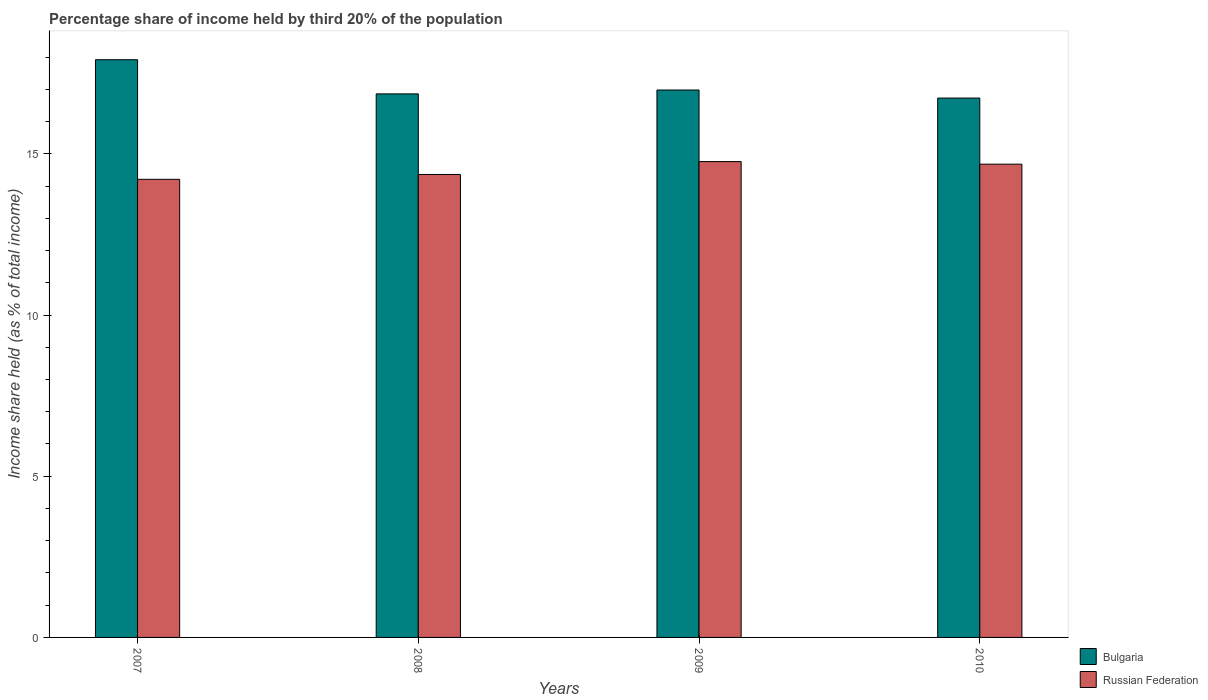How many different coloured bars are there?
Provide a short and direct response. 2. Are the number of bars on each tick of the X-axis equal?
Ensure brevity in your answer.  Yes. How many bars are there on the 4th tick from the left?
Give a very brief answer. 2. What is the label of the 3rd group of bars from the left?
Give a very brief answer. 2009. In how many cases, is the number of bars for a given year not equal to the number of legend labels?
Offer a terse response. 0. What is the share of income held by third 20% of the population in Russian Federation in 2007?
Your answer should be very brief. 14.21. Across all years, what is the maximum share of income held by third 20% of the population in Russian Federation?
Ensure brevity in your answer.  14.76. Across all years, what is the minimum share of income held by third 20% of the population in Russian Federation?
Give a very brief answer. 14.21. In which year was the share of income held by third 20% of the population in Bulgaria minimum?
Offer a terse response. 2010. What is the total share of income held by third 20% of the population in Bulgaria in the graph?
Your answer should be compact. 68.49. What is the difference between the share of income held by third 20% of the population in Bulgaria in 2008 and that in 2009?
Your answer should be compact. -0.12. What is the difference between the share of income held by third 20% of the population in Bulgaria in 2007 and the share of income held by third 20% of the population in Russian Federation in 2008?
Offer a very short reply. 3.56. What is the average share of income held by third 20% of the population in Bulgaria per year?
Offer a very short reply. 17.12. In the year 2007, what is the difference between the share of income held by third 20% of the population in Bulgaria and share of income held by third 20% of the population in Russian Federation?
Offer a very short reply. 3.71. In how many years, is the share of income held by third 20% of the population in Bulgaria greater than 16 %?
Make the answer very short. 4. What is the ratio of the share of income held by third 20% of the population in Bulgaria in 2008 to that in 2010?
Give a very brief answer. 1.01. Is the share of income held by third 20% of the population in Bulgaria in 2007 less than that in 2008?
Your answer should be compact. No. What is the difference between the highest and the second highest share of income held by third 20% of the population in Russian Federation?
Give a very brief answer. 0.08. What is the difference between the highest and the lowest share of income held by third 20% of the population in Russian Federation?
Your response must be concise. 0.55. In how many years, is the share of income held by third 20% of the population in Russian Federation greater than the average share of income held by third 20% of the population in Russian Federation taken over all years?
Make the answer very short. 2. Is the sum of the share of income held by third 20% of the population in Bulgaria in 2007 and 2008 greater than the maximum share of income held by third 20% of the population in Russian Federation across all years?
Provide a succinct answer. Yes. What does the 1st bar from the right in 2007 represents?
Provide a short and direct response. Russian Federation. Are all the bars in the graph horizontal?
Your answer should be very brief. No. What is the difference between two consecutive major ticks on the Y-axis?
Offer a terse response. 5. Are the values on the major ticks of Y-axis written in scientific E-notation?
Make the answer very short. No. How are the legend labels stacked?
Make the answer very short. Vertical. What is the title of the graph?
Offer a terse response. Percentage share of income held by third 20% of the population. What is the label or title of the Y-axis?
Your response must be concise. Income share held (as % of total income). What is the Income share held (as % of total income) of Bulgaria in 2007?
Make the answer very short. 17.92. What is the Income share held (as % of total income) of Russian Federation in 2007?
Ensure brevity in your answer.  14.21. What is the Income share held (as % of total income) in Bulgaria in 2008?
Keep it short and to the point. 16.86. What is the Income share held (as % of total income) in Russian Federation in 2008?
Your answer should be very brief. 14.36. What is the Income share held (as % of total income) of Bulgaria in 2009?
Give a very brief answer. 16.98. What is the Income share held (as % of total income) of Russian Federation in 2009?
Provide a succinct answer. 14.76. What is the Income share held (as % of total income) in Bulgaria in 2010?
Your response must be concise. 16.73. What is the Income share held (as % of total income) in Russian Federation in 2010?
Offer a terse response. 14.68. Across all years, what is the maximum Income share held (as % of total income) of Bulgaria?
Keep it short and to the point. 17.92. Across all years, what is the maximum Income share held (as % of total income) of Russian Federation?
Your answer should be compact. 14.76. Across all years, what is the minimum Income share held (as % of total income) in Bulgaria?
Provide a short and direct response. 16.73. Across all years, what is the minimum Income share held (as % of total income) of Russian Federation?
Offer a very short reply. 14.21. What is the total Income share held (as % of total income) in Bulgaria in the graph?
Ensure brevity in your answer.  68.49. What is the total Income share held (as % of total income) of Russian Federation in the graph?
Offer a very short reply. 58.01. What is the difference between the Income share held (as % of total income) of Bulgaria in 2007 and that in 2008?
Your answer should be compact. 1.06. What is the difference between the Income share held (as % of total income) in Bulgaria in 2007 and that in 2009?
Provide a succinct answer. 0.94. What is the difference between the Income share held (as % of total income) of Russian Federation in 2007 and that in 2009?
Offer a terse response. -0.55. What is the difference between the Income share held (as % of total income) of Bulgaria in 2007 and that in 2010?
Offer a very short reply. 1.19. What is the difference between the Income share held (as % of total income) of Russian Federation in 2007 and that in 2010?
Give a very brief answer. -0.47. What is the difference between the Income share held (as % of total income) of Bulgaria in 2008 and that in 2009?
Offer a very short reply. -0.12. What is the difference between the Income share held (as % of total income) in Bulgaria in 2008 and that in 2010?
Provide a short and direct response. 0.13. What is the difference between the Income share held (as % of total income) in Russian Federation in 2008 and that in 2010?
Make the answer very short. -0.32. What is the difference between the Income share held (as % of total income) of Bulgaria in 2007 and the Income share held (as % of total income) of Russian Federation in 2008?
Your answer should be compact. 3.56. What is the difference between the Income share held (as % of total income) of Bulgaria in 2007 and the Income share held (as % of total income) of Russian Federation in 2009?
Offer a very short reply. 3.16. What is the difference between the Income share held (as % of total income) of Bulgaria in 2007 and the Income share held (as % of total income) of Russian Federation in 2010?
Keep it short and to the point. 3.24. What is the difference between the Income share held (as % of total income) of Bulgaria in 2008 and the Income share held (as % of total income) of Russian Federation in 2009?
Ensure brevity in your answer.  2.1. What is the difference between the Income share held (as % of total income) in Bulgaria in 2008 and the Income share held (as % of total income) in Russian Federation in 2010?
Provide a short and direct response. 2.18. What is the average Income share held (as % of total income) of Bulgaria per year?
Ensure brevity in your answer.  17.12. What is the average Income share held (as % of total income) of Russian Federation per year?
Give a very brief answer. 14.5. In the year 2007, what is the difference between the Income share held (as % of total income) in Bulgaria and Income share held (as % of total income) in Russian Federation?
Offer a very short reply. 3.71. In the year 2008, what is the difference between the Income share held (as % of total income) of Bulgaria and Income share held (as % of total income) of Russian Federation?
Your answer should be very brief. 2.5. In the year 2009, what is the difference between the Income share held (as % of total income) in Bulgaria and Income share held (as % of total income) in Russian Federation?
Keep it short and to the point. 2.22. In the year 2010, what is the difference between the Income share held (as % of total income) in Bulgaria and Income share held (as % of total income) in Russian Federation?
Offer a terse response. 2.05. What is the ratio of the Income share held (as % of total income) in Bulgaria in 2007 to that in 2008?
Provide a succinct answer. 1.06. What is the ratio of the Income share held (as % of total income) of Russian Federation in 2007 to that in 2008?
Keep it short and to the point. 0.99. What is the ratio of the Income share held (as % of total income) in Bulgaria in 2007 to that in 2009?
Make the answer very short. 1.06. What is the ratio of the Income share held (as % of total income) in Russian Federation in 2007 to that in 2009?
Keep it short and to the point. 0.96. What is the ratio of the Income share held (as % of total income) of Bulgaria in 2007 to that in 2010?
Offer a terse response. 1.07. What is the ratio of the Income share held (as % of total income) of Bulgaria in 2008 to that in 2009?
Offer a terse response. 0.99. What is the ratio of the Income share held (as % of total income) in Russian Federation in 2008 to that in 2009?
Your answer should be very brief. 0.97. What is the ratio of the Income share held (as % of total income) of Bulgaria in 2008 to that in 2010?
Provide a succinct answer. 1.01. What is the ratio of the Income share held (as % of total income) of Russian Federation in 2008 to that in 2010?
Provide a succinct answer. 0.98. What is the ratio of the Income share held (as % of total income) of Bulgaria in 2009 to that in 2010?
Offer a terse response. 1.01. What is the ratio of the Income share held (as % of total income) in Russian Federation in 2009 to that in 2010?
Your answer should be compact. 1.01. What is the difference between the highest and the lowest Income share held (as % of total income) of Bulgaria?
Your response must be concise. 1.19. What is the difference between the highest and the lowest Income share held (as % of total income) in Russian Federation?
Your answer should be very brief. 0.55. 